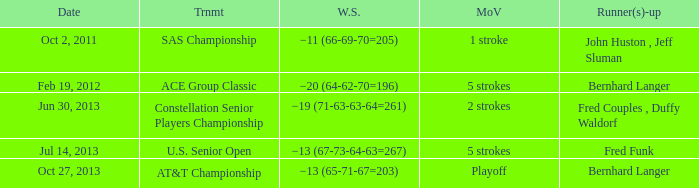Which Tournament has a Date of jul 14, 2013? U.S. Senior Open. 